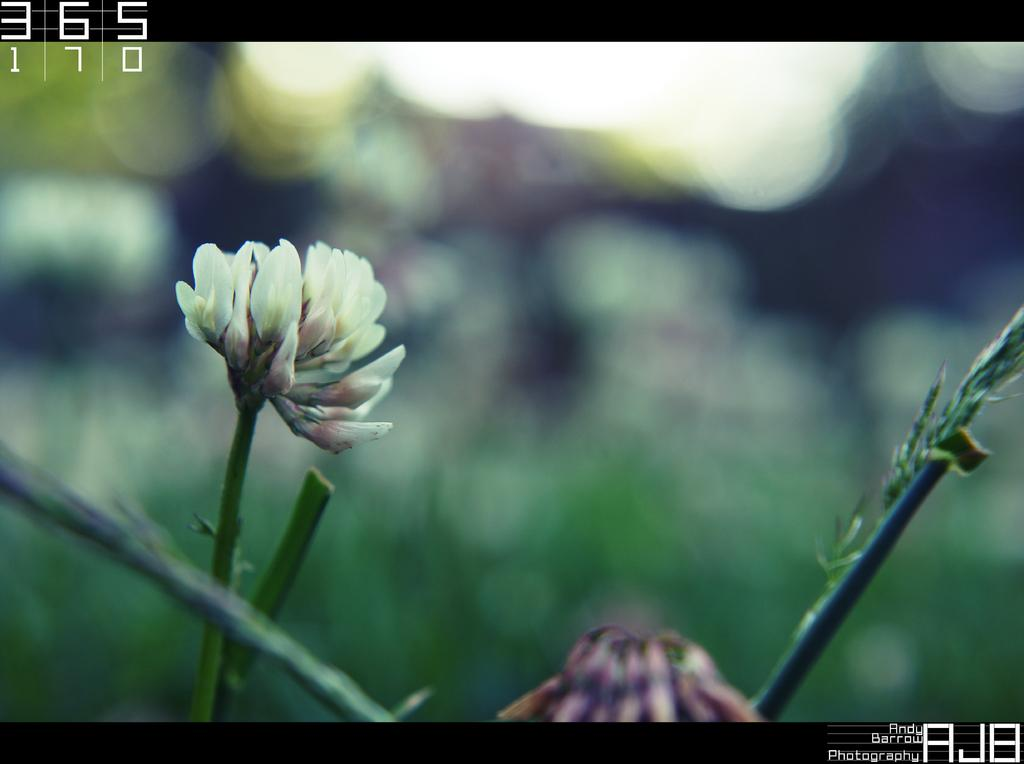What is the main subject of the image? There is a flower in the image. Can you describe any other parts of the flower that are visible? There are stems visible in the image. What type of plants can be seen growing near the airport in the image? There is no airport or additional plants present in the image; it only features a flower and its stems. We focus on the given facts and avoid making assumptions or asking questions about elements that are not present in the image. Absurd Question/Answer: What is the flower stored in within the image? The image does not show the flower being stored in a jar or any other container. 